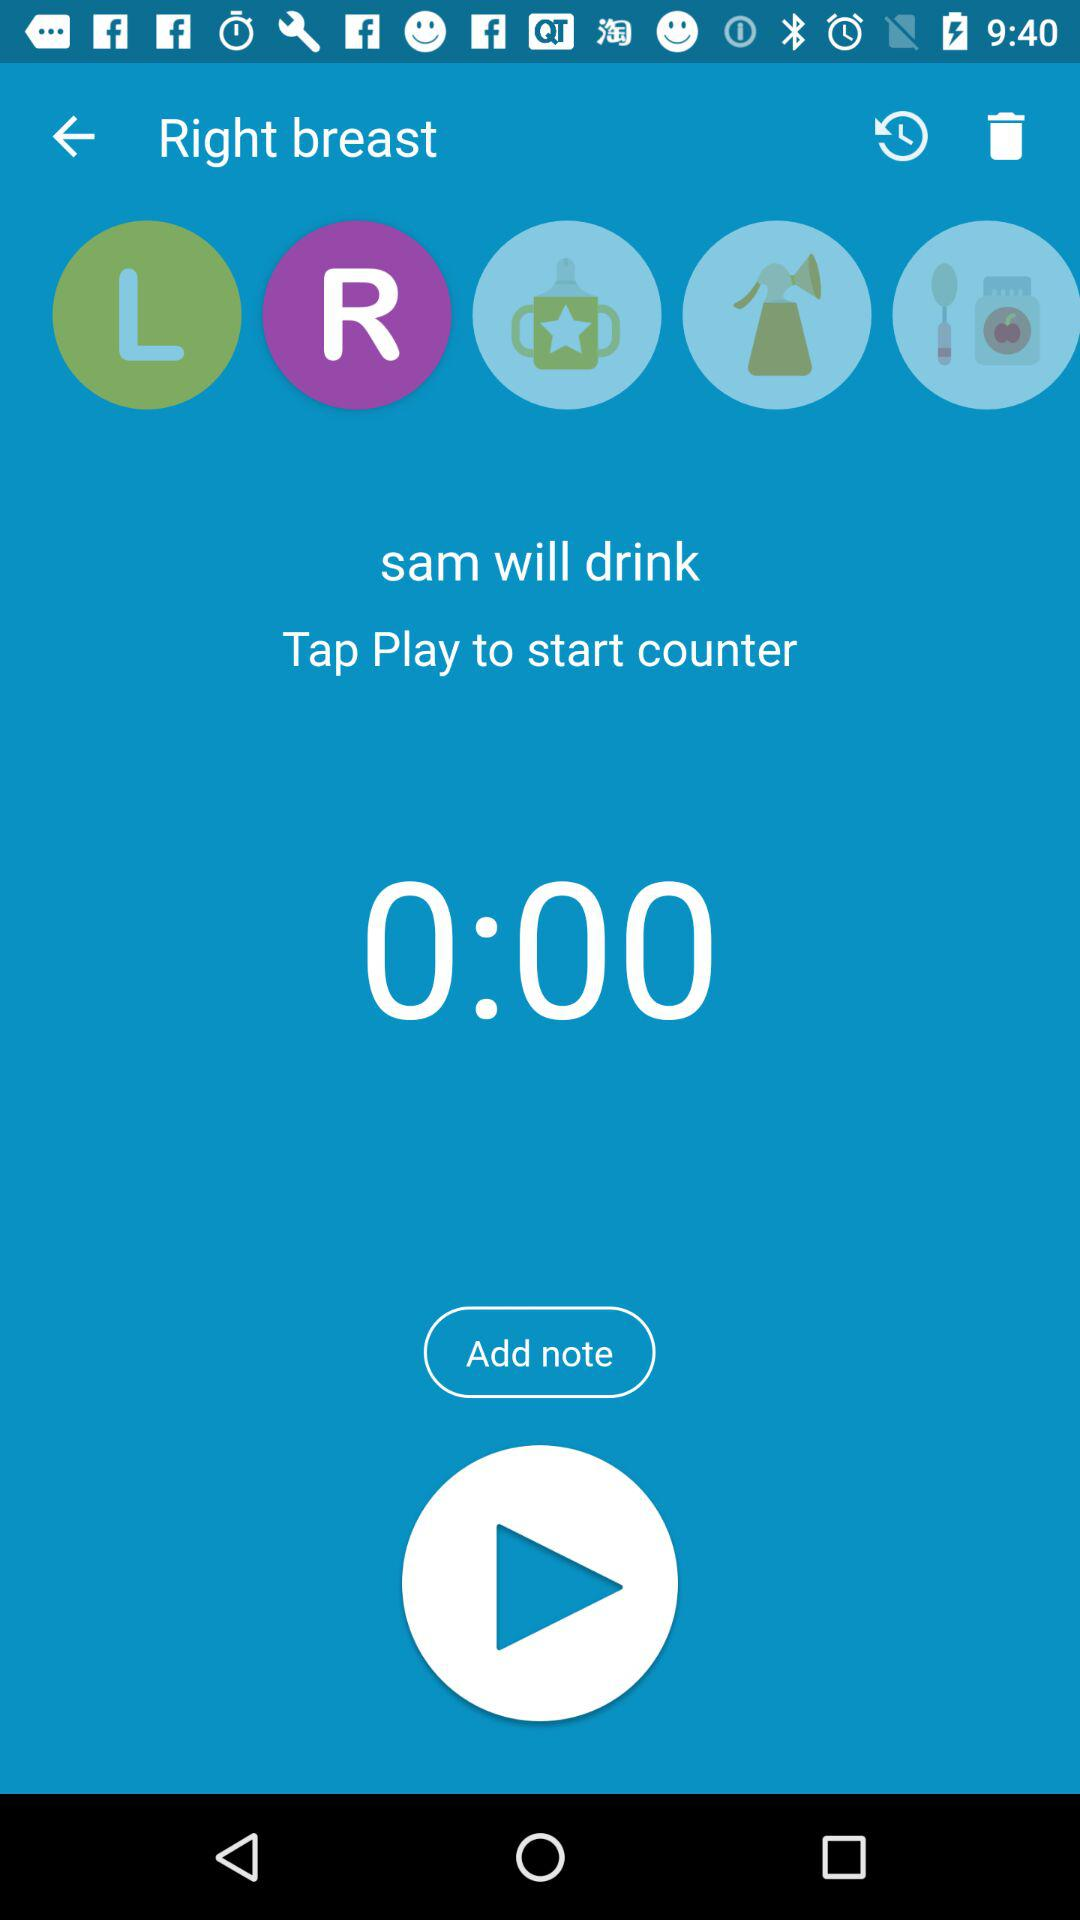What button should I tap to start the counter? Tap play to start the counter. 